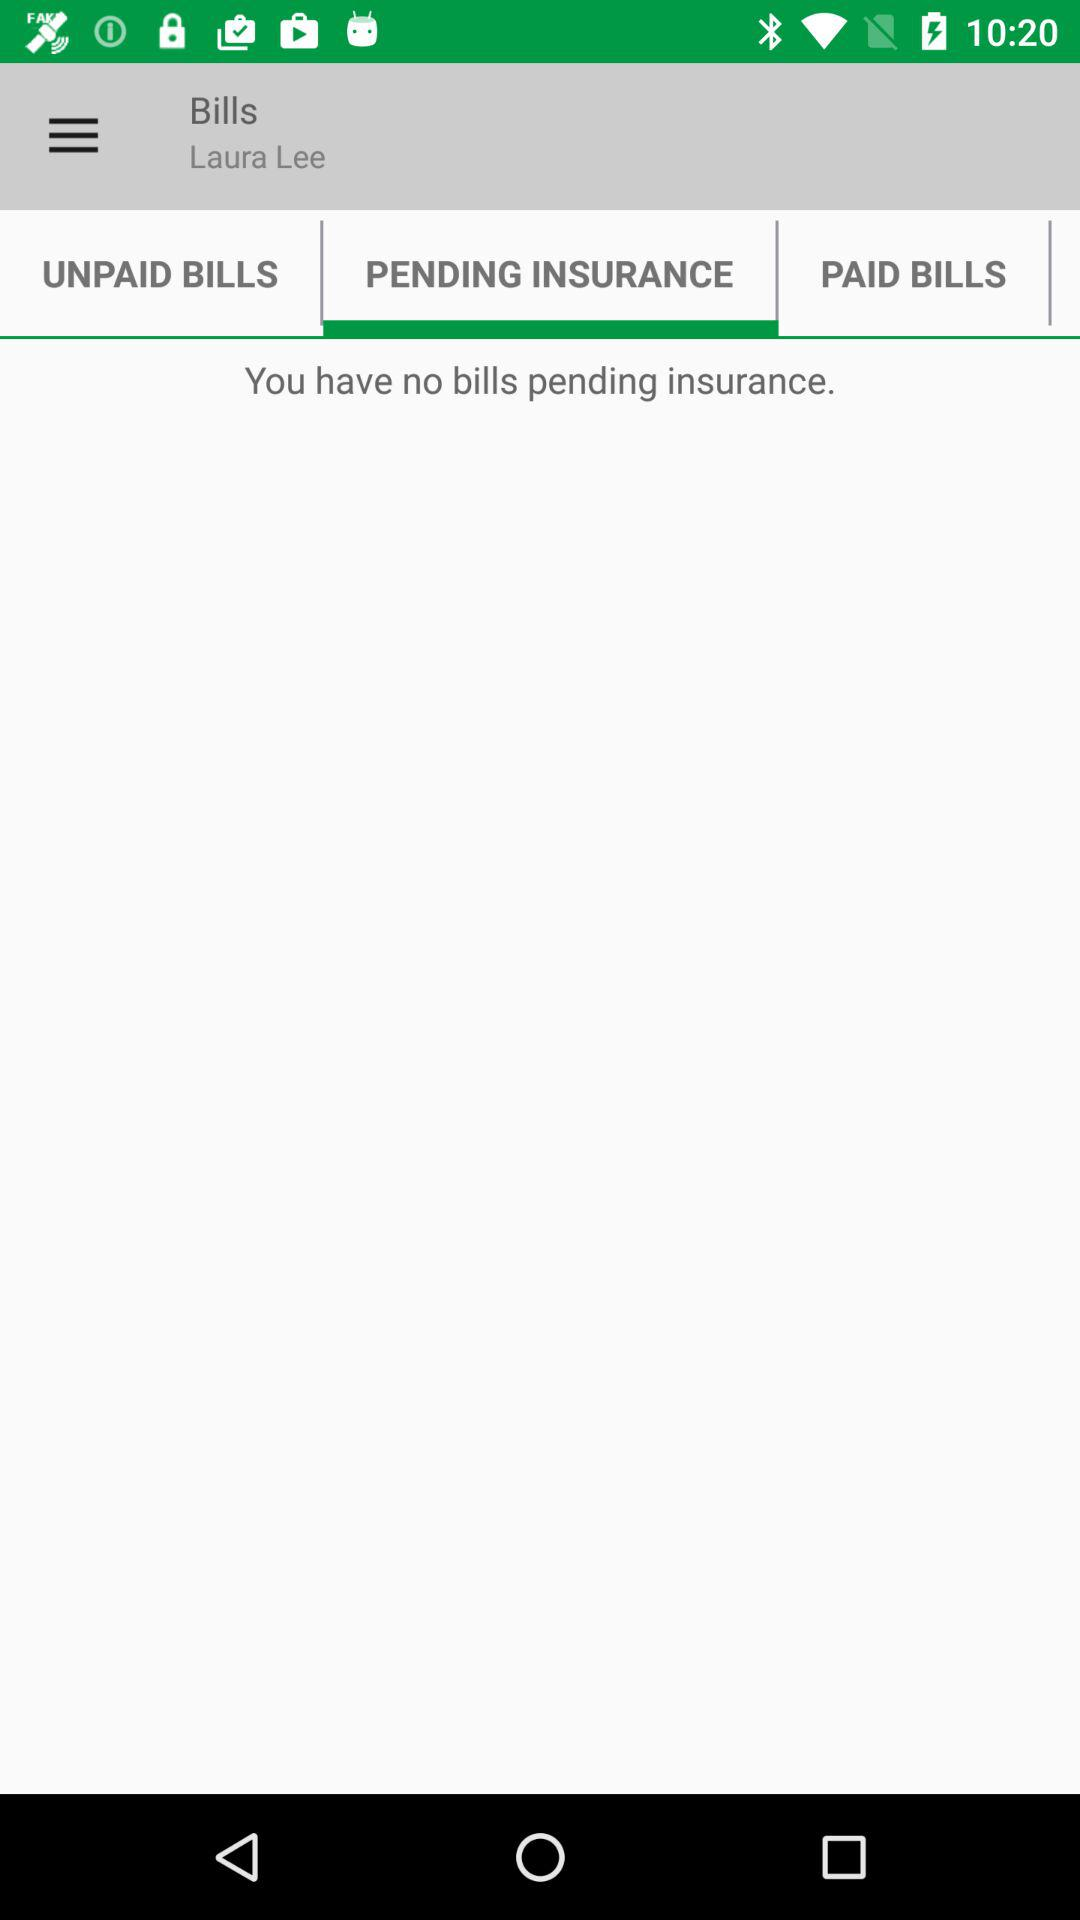How many bills are pending insurance?
Answer the question using a single word or phrase. 0 